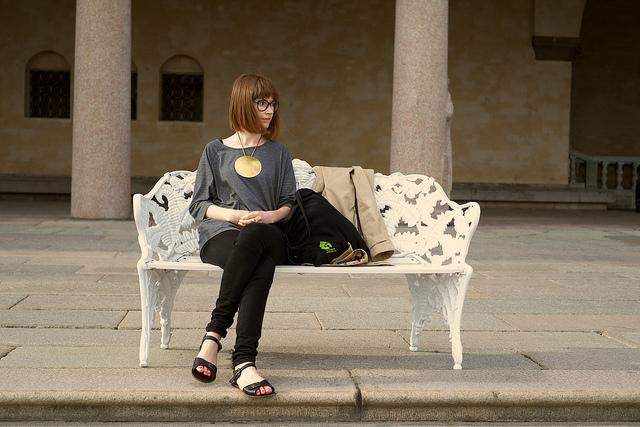How many people are depicted?
Write a very short answer. 1. What is the bench made of?
Be succinct. Metal. What is she waiting for?
Answer briefly. Bus. 